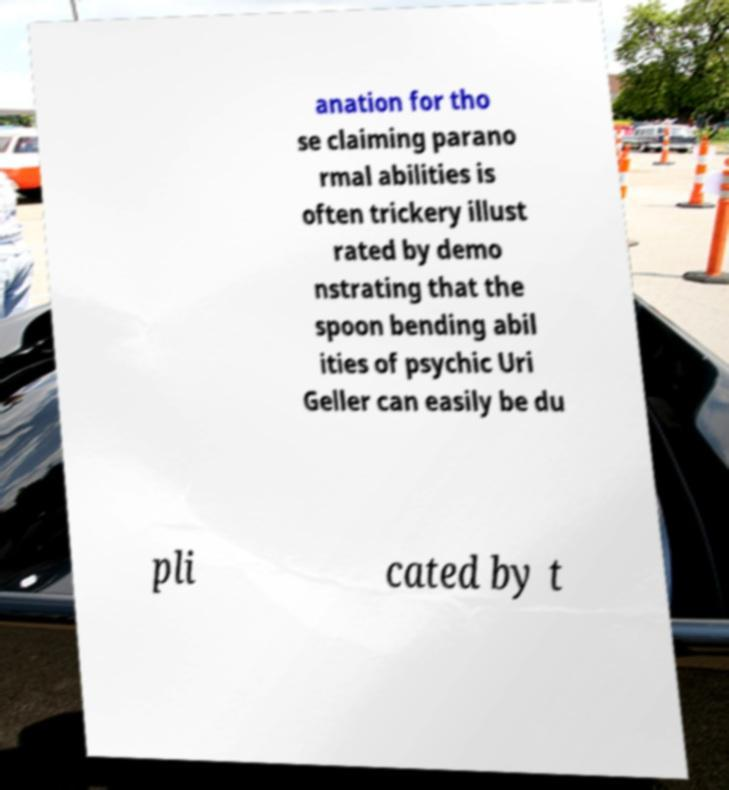Can you read and provide the text displayed in the image?This photo seems to have some interesting text. Can you extract and type it out for me? anation for tho se claiming parano rmal abilities is often trickery illust rated by demo nstrating that the spoon bending abil ities of psychic Uri Geller can easily be du pli cated by t 